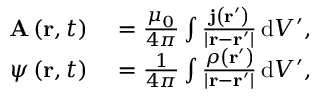Convert formula to latex. <formula><loc_0><loc_0><loc_500><loc_500>\begin{array} { r l } { A \left ( r , t \right ) } & = { \frac { \mu _ { 0 } } { 4 \pi } } \int { \frac { j \left ( r ^ { \prime } \right ) } { \left | r - r ^ { \prime } \right | } } \, d V ^ { \prime } , } \\ { \psi \left ( r , t \right ) } & = { \frac { 1 } { 4 \pi } } \int { \frac { \rho \left ( r ^ { \prime } \right ) } { \left | r - r ^ { \prime } \right | } } \, d V ^ { \prime } , } \end{array}</formula> 